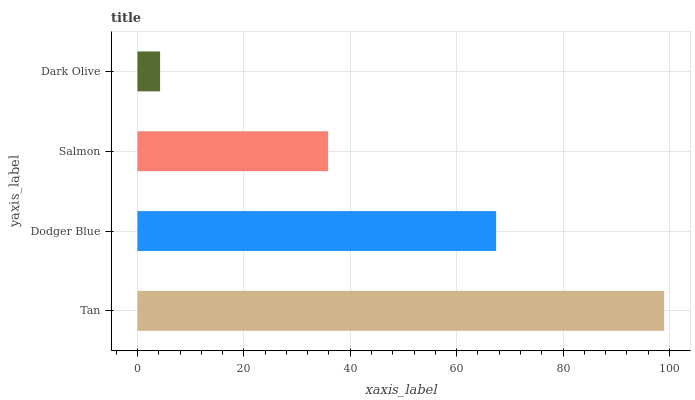Is Dark Olive the minimum?
Answer yes or no. Yes. Is Tan the maximum?
Answer yes or no. Yes. Is Dodger Blue the minimum?
Answer yes or no. No. Is Dodger Blue the maximum?
Answer yes or no. No. Is Tan greater than Dodger Blue?
Answer yes or no. Yes. Is Dodger Blue less than Tan?
Answer yes or no. Yes. Is Dodger Blue greater than Tan?
Answer yes or no. No. Is Tan less than Dodger Blue?
Answer yes or no. No. Is Dodger Blue the high median?
Answer yes or no. Yes. Is Salmon the low median?
Answer yes or no. Yes. Is Dark Olive the high median?
Answer yes or no. No. Is Tan the low median?
Answer yes or no. No. 